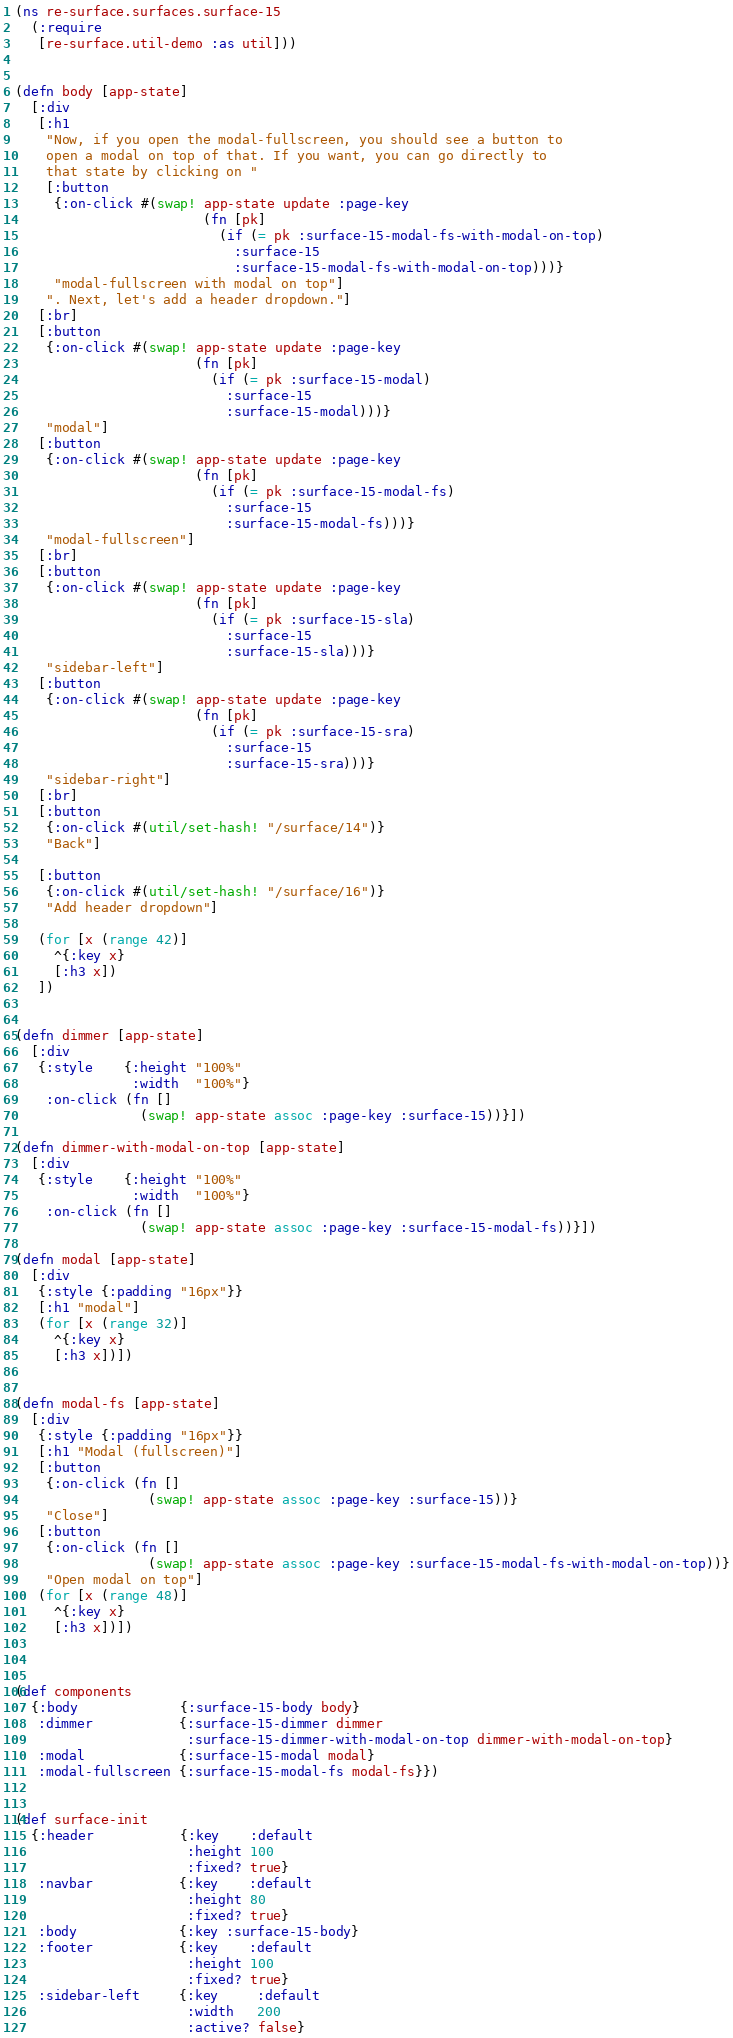<code> <loc_0><loc_0><loc_500><loc_500><_Clojure_>(ns re-surface.surfaces.surface-15
  (:require
   [re-surface.util-demo :as util]))


(defn body [app-state]
  [:div
   [:h1
    "Now, if you open the modal-fullscreen, you should see a button to
    open a modal on top of that. If you want, you can go directly to
    that state by clicking on "
    [:button
     {:on-click #(swap! app-state update :page-key
                        (fn [pk]
                          (if (= pk :surface-15-modal-fs-with-modal-on-top)
                            :surface-15
                            :surface-15-modal-fs-with-modal-on-top)))}
     "modal-fullscreen with modal on top"]
    ". Next, let's add a header dropdown."]
   [:br]
   [:button
    {:on-click #(swap! app-state update :page-key
                       (fn [pk]
                         (if (= pk :surface-15-modal)
                           :surface-15
                           :surface-15-modal)))}
    "modal"]
   [:button
    {:on-click #(swap! app-state update :page-key
                       (fn [pk]
                         (if (= pk :surface-15-modal-fs)
                           :surface-15
                           :surface-15-modal-fs)))}
    "modal-fullscreen"]
   [:br]
   [:button
    {:on-click #(swap! app-state update :page-key
                       (fn [pk]
                         (if (= pk :surface-15-sla)
                           :surface-15
                           :surface-15-sla)))}
    "sidebar-left"]
   [:button
    {:on-click #(swap! app-state update :page-key
                       (fn [pk]
                         (if (= pk :surface-15-sra)
                           :surface-15
                           :surface-15-sra)))}
    "sidebar-right"]
   [:br]
   [:button
    {:on-click #(util/set-hash! "/surface/14")}
    "Back"]

   [:button
    {:on-click #(util/set-hash! "/surface/16")}
    "Add header dropdown"]

   (for [x (range 42)]
     ^{:key x}
     [:h3 x])
   ])


(defn dimmer [app-state]
  [:div
   {:style    {:height "100%"
               :width  "100%"}
    :on-click (fn []
                (swap! app-state assoc :page-key :surface-15))}])

(defn dimmer-with-modal-on-top [app-state]
  [:div
   {:style    {:height "100%"
               :width  "100%"}
    :on-click (fn []
                (swap! app-state assoc :page-key :surface-15-modal-fs))}])

(defn modal [app-state]
  [:div
   {:style {:padding "16px"}}
   [:h1 "modal"]
   (for [x (range 32)]
     ^{:key x}
     [:h3 x])])


(defn modal-fs [app-state]
  [:div
   {:style {:padding "16px"}}
   [:h1 "Modal (fullscreen)"]
   [:button
    {:on-click (fn []
                 (swap! app-state assoc :page-key :surface-15))}
    "Close"]
   [:button
    {:on-click (fn []
                 (swap! app-state assoc :page-key :surface-15-modal-fs-with-modal-on-top))}
    "Open modal on top"]
   (for [x (range 48)]
     ^{:key x}
     [:h3 x])])



(def components
  {:body             {:surface-15-body body}
   :dimmer           {:surface-15-dimmer dimmer
                      :surface-15-dimmer-with-modal-on-top dimmer-with-modal-on-top}
   :modal            {:surface-15-modal modal}
   :modal-fullscreen {:surface-15-modal-fs modal-fs}})


(def surface-init
  {:header           {:key    :default
                      :height 100
                      :fixed? true}
   :navbar           {:key    :default
                      :height 80
                      :fixed? true}
   :body             {:key :surface-15-body}
   :footer           {:key    :default
                      :height 100
                      :fixed? true}
   :sidebar-left     {:key     :default
                      :width   200
                      :active? false}</code> 